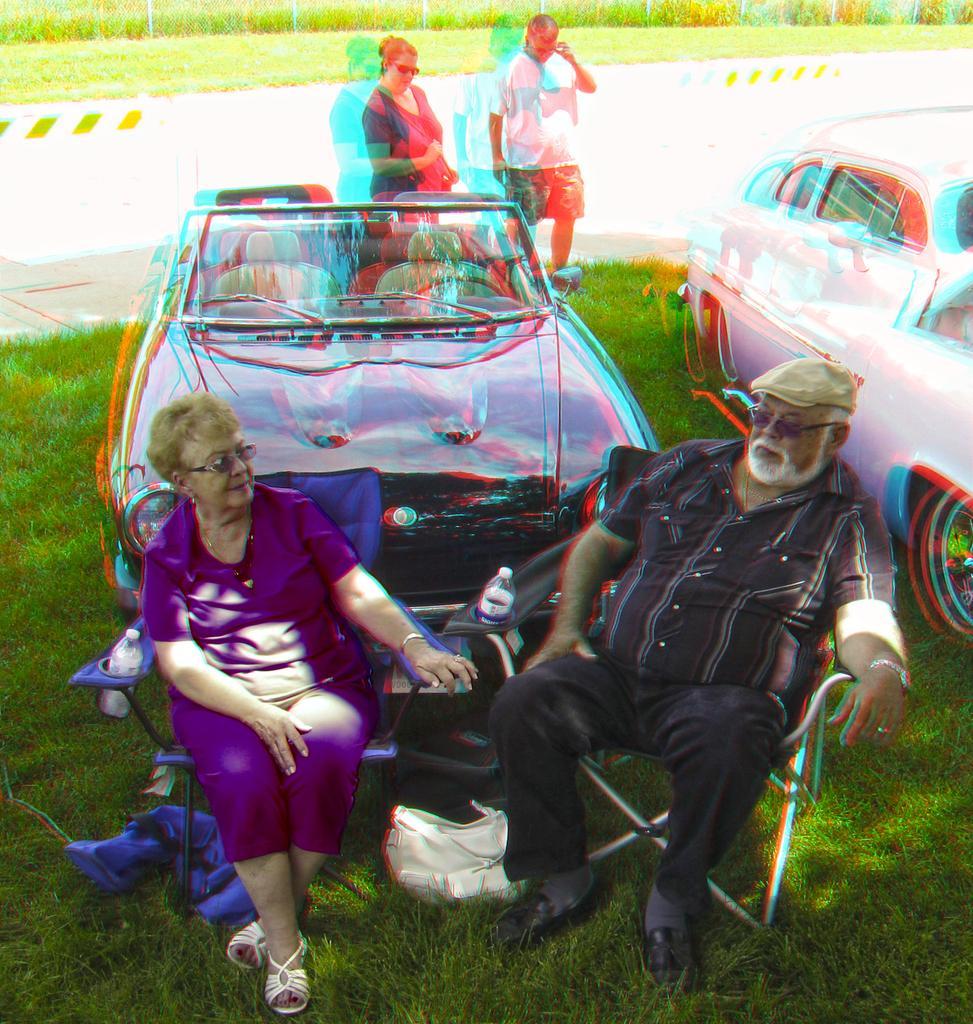How would you summarize this image in a sentence or two? In this image we can see two vehicles, two persons sitting on the chairs and two of them are standing on the grass, behind them, we can see a road, fences, grass and a few plants. 